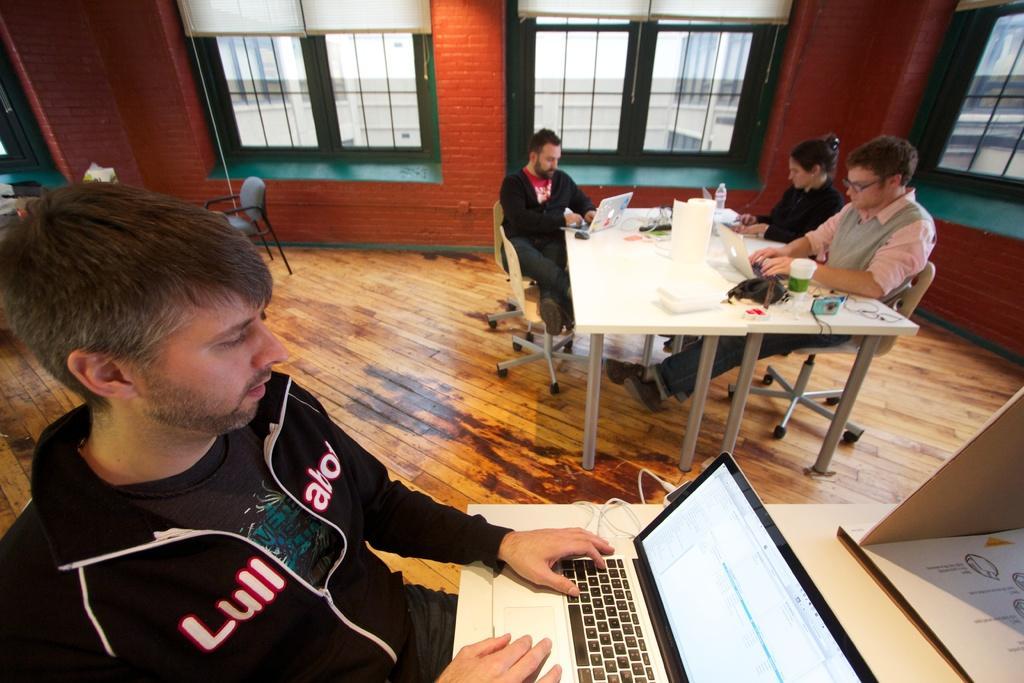Please provide a concise description of this image. In the picture we can see four people, one man is sitting on the chair near to the table and working something in the laptop, in the next table there are three chairs with three people one is woman and two are men and working something in their laptops and on the table we can find a bottle, a camera with some bag, in the background we can see a windows which are green in color and red wall near to it there is a chair. 